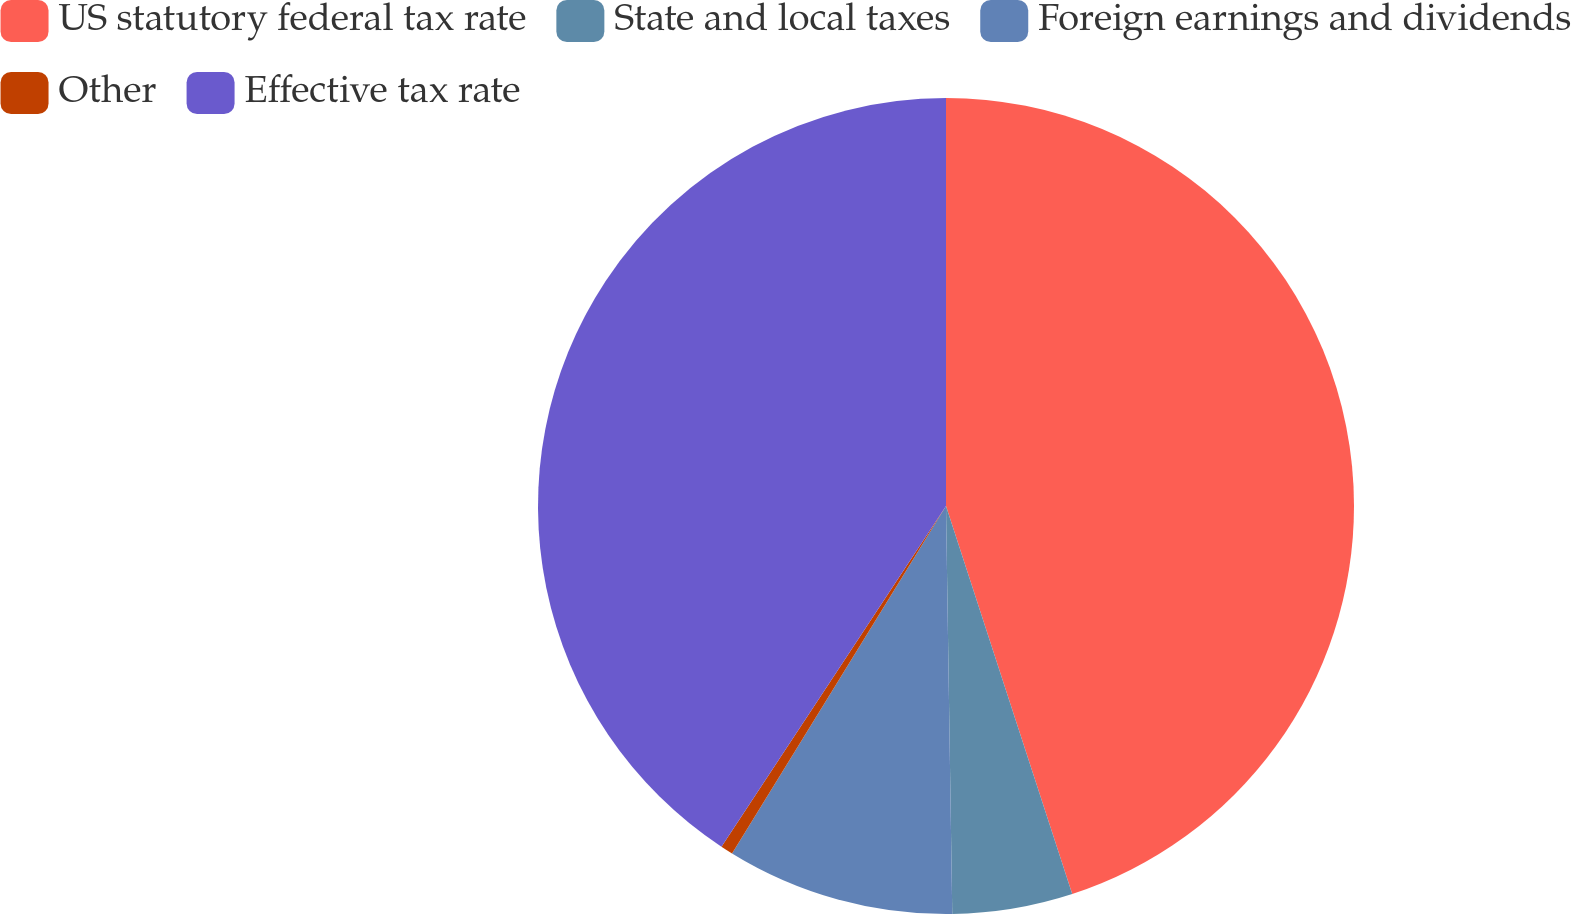Convert chart. <chart><loc_0><loc_0><loc_500><loc_500><pie_chart><fcel>US statutory federal tax rate<fcel>State and local taxes<fcel>Foreign earnings and dividends<fcel>Other<fcel>Effective tax rate<nl><fcel>44.99%<fcel>4.76%<fcel>9.03%<fcel>0.49%<fcel>40.72%<nl></chart> 